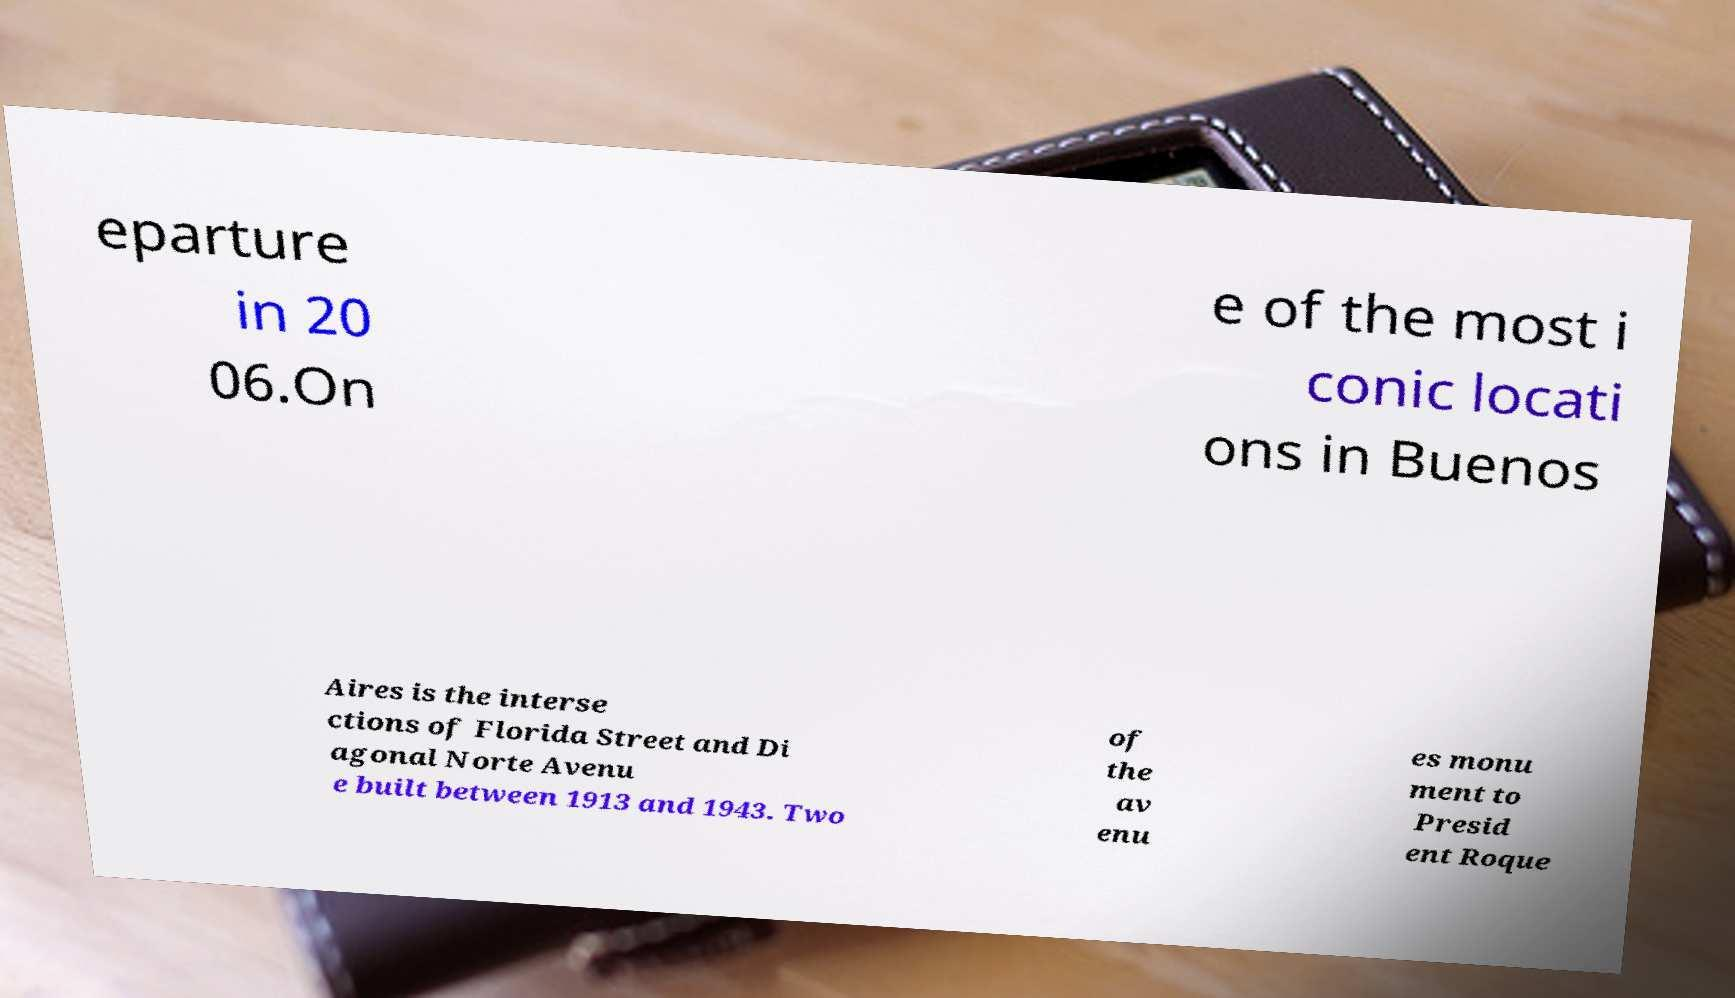Please read and relay the text visible in this image. What does it say? eparture in 20 06.On e of the most i conic locati ons in Buenos Aires is the interse ctions of Florida Street and Di agonal Norte Avenu e built between 1913 and 1943. Two of the av enu es monu ment to Presid ent Roque 